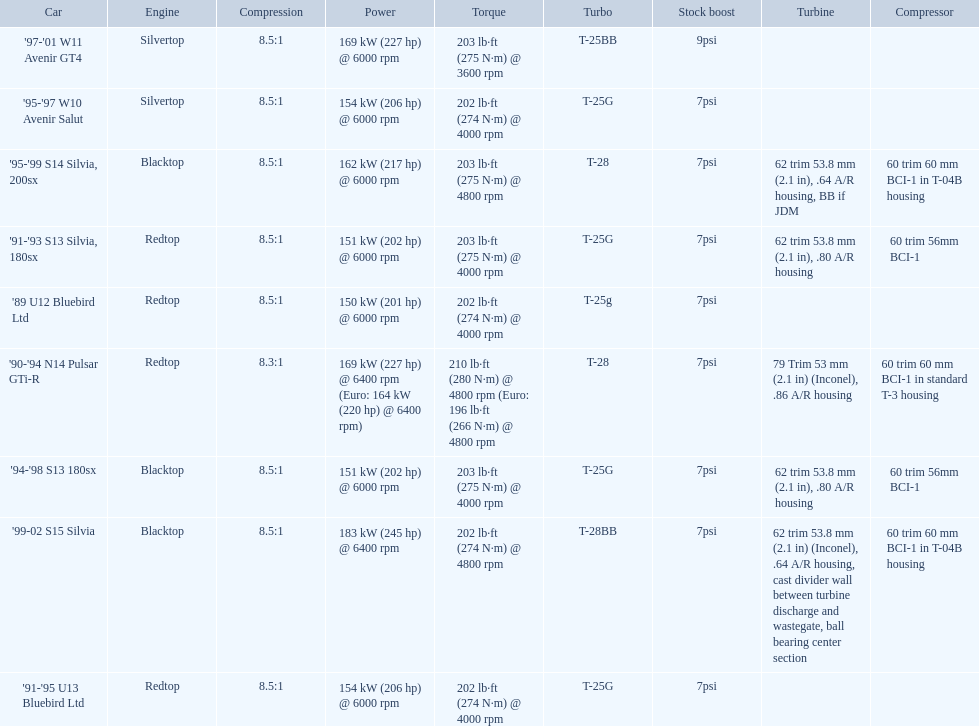Which cars featured blacktop engines? '94-'98 S13 180sx, '95-'99 S14 Silvia, 200sx, '99-02 S15 Silvia. Which of these had t-04b compressor housings? '95-'99 S14 Silvia, 200sx, '99-02 S15 Silvia. Which one of these has the highest horsepower? '99-02 S15 Silvia. Could you parse the entire table? {'header': ['Car', 'Engine', 'Compression', 'Power', 'Torque', 'Turbo', 'Stock boost', 'Turbine', 'Compressor'], 'rows': [["'97-'01 W11 Avenir GT4", 'Silvertop', '8.5:1', '169\xa0kW (227\xa0hp) @ 6000 rpm', '203\xa0lb·ft (275\xa0N·m) @ 3600 rpm', 'T-25BB', '9psi', '', ''], ["'95-'97 W10 Avenir Salut", 'Silvertop', '8.5:1', '154\xa0kW (206\xa0hp) @ 6000 rpm', '202\xa0lb·ft (274\xa0N·m) @ 4000 rpm', 'T-25G', '7psi', '', ''], ["'95-'99 S14 Silvia, 200sx", 'Blacktop', '8.5:1', '162\xa0kW (217\xa0hp) @ 6000 rpm', '203\xa0lb·ft (275\xa0N·m) @ 4800 rpm', 'T-28', '7psi', '62 trim 53.8\xa0mm (2.1\xa0in), .64 A/R housing, BB if JDM', '60 trim 60\xa0mm BCI-1 in T-04B housing'], ["'91-'93 S13 Silvia, 180sx", 'Redtop', '8.5:1', '151\xa0kW (202\xa0hp) @ 6000 rpm', '203\xa0lb·ft (275\xa0N·m) @ 4000 rpm', 'T-25G', '7psi', '62 trim 53.8\xa0mm (2.1\xa0in), .80 A/R housing', '60 trim 56mm BCI-1'], ["'89 U12 Bluebird Ltd", 'Redtop', '8.5:1', '150\xa0kW (201\xa0hp) @ 6000 rpm', '202\xa0lb·ft (274\xa0N·m) @ 4000 rpm', 'T-25g', '7psi', '', ''], ["'90-'94 N14 Pulsar GTi-R", 'Redtop', '8.3:1', '169\xa0kW (227\xa0hp) @ 6400 rpm (Euro: 164\xa0kW (220\xa0hp) @ 6400 rpm)', '210\xa0lb·ft (280\xa0N·m) @ 4800 rpm (Euro: 196\xa0lb·ft (266\xa0N·m) @ 4800 rpm', 'T-28', '7psi', '79 Trim 53\xa0mm (2.1\xa0in) (Inconel), .86 A/R housing', '60 trim 60\xa0mm BCI-1 in standard T-3 housing'], ["'94-'98 S13 180sx", 'Blacktop', '8.5:1', '151\xa0kW (202\xa0hp) @ 6000 rpm', '203\xa0lb·ft (275\xa0N·m) @ 4000 rpm', 'T-25G', '7psi', '62 trim 53.8\xa0mm (2.1\xa0in), .80 A/R housing', '60 trim 56mm BCI-1'], ["'99-02 S15 Silvia", 'Blacktop', '8.5:1', '183\xa0kW (245\xa0hp) @ 6400 rpm', '202\xa0lb·ft (274\xa0N·m) @ 4800 rpm', 'T-28BB', '7psi', '62 trim 53.8\xa0mm (2.1\xa0in) (Inconel), .64 A/R housing, cast divider wall between turbine discharge and wastegate, ball bearing center section', '60 trim 60\xa0mm BCI-1 in T-04B housing'], ["'91-'95 U13 Bluebird Ltd", 'Redtop', '8.5:1', '154\xa0kW (206\xa0hp) @ 6000 rpm', '202\xa0lb·ft (274\xa0N·m) @ 4000 rpm', 'T-25G', '7psi', '', '']]} 